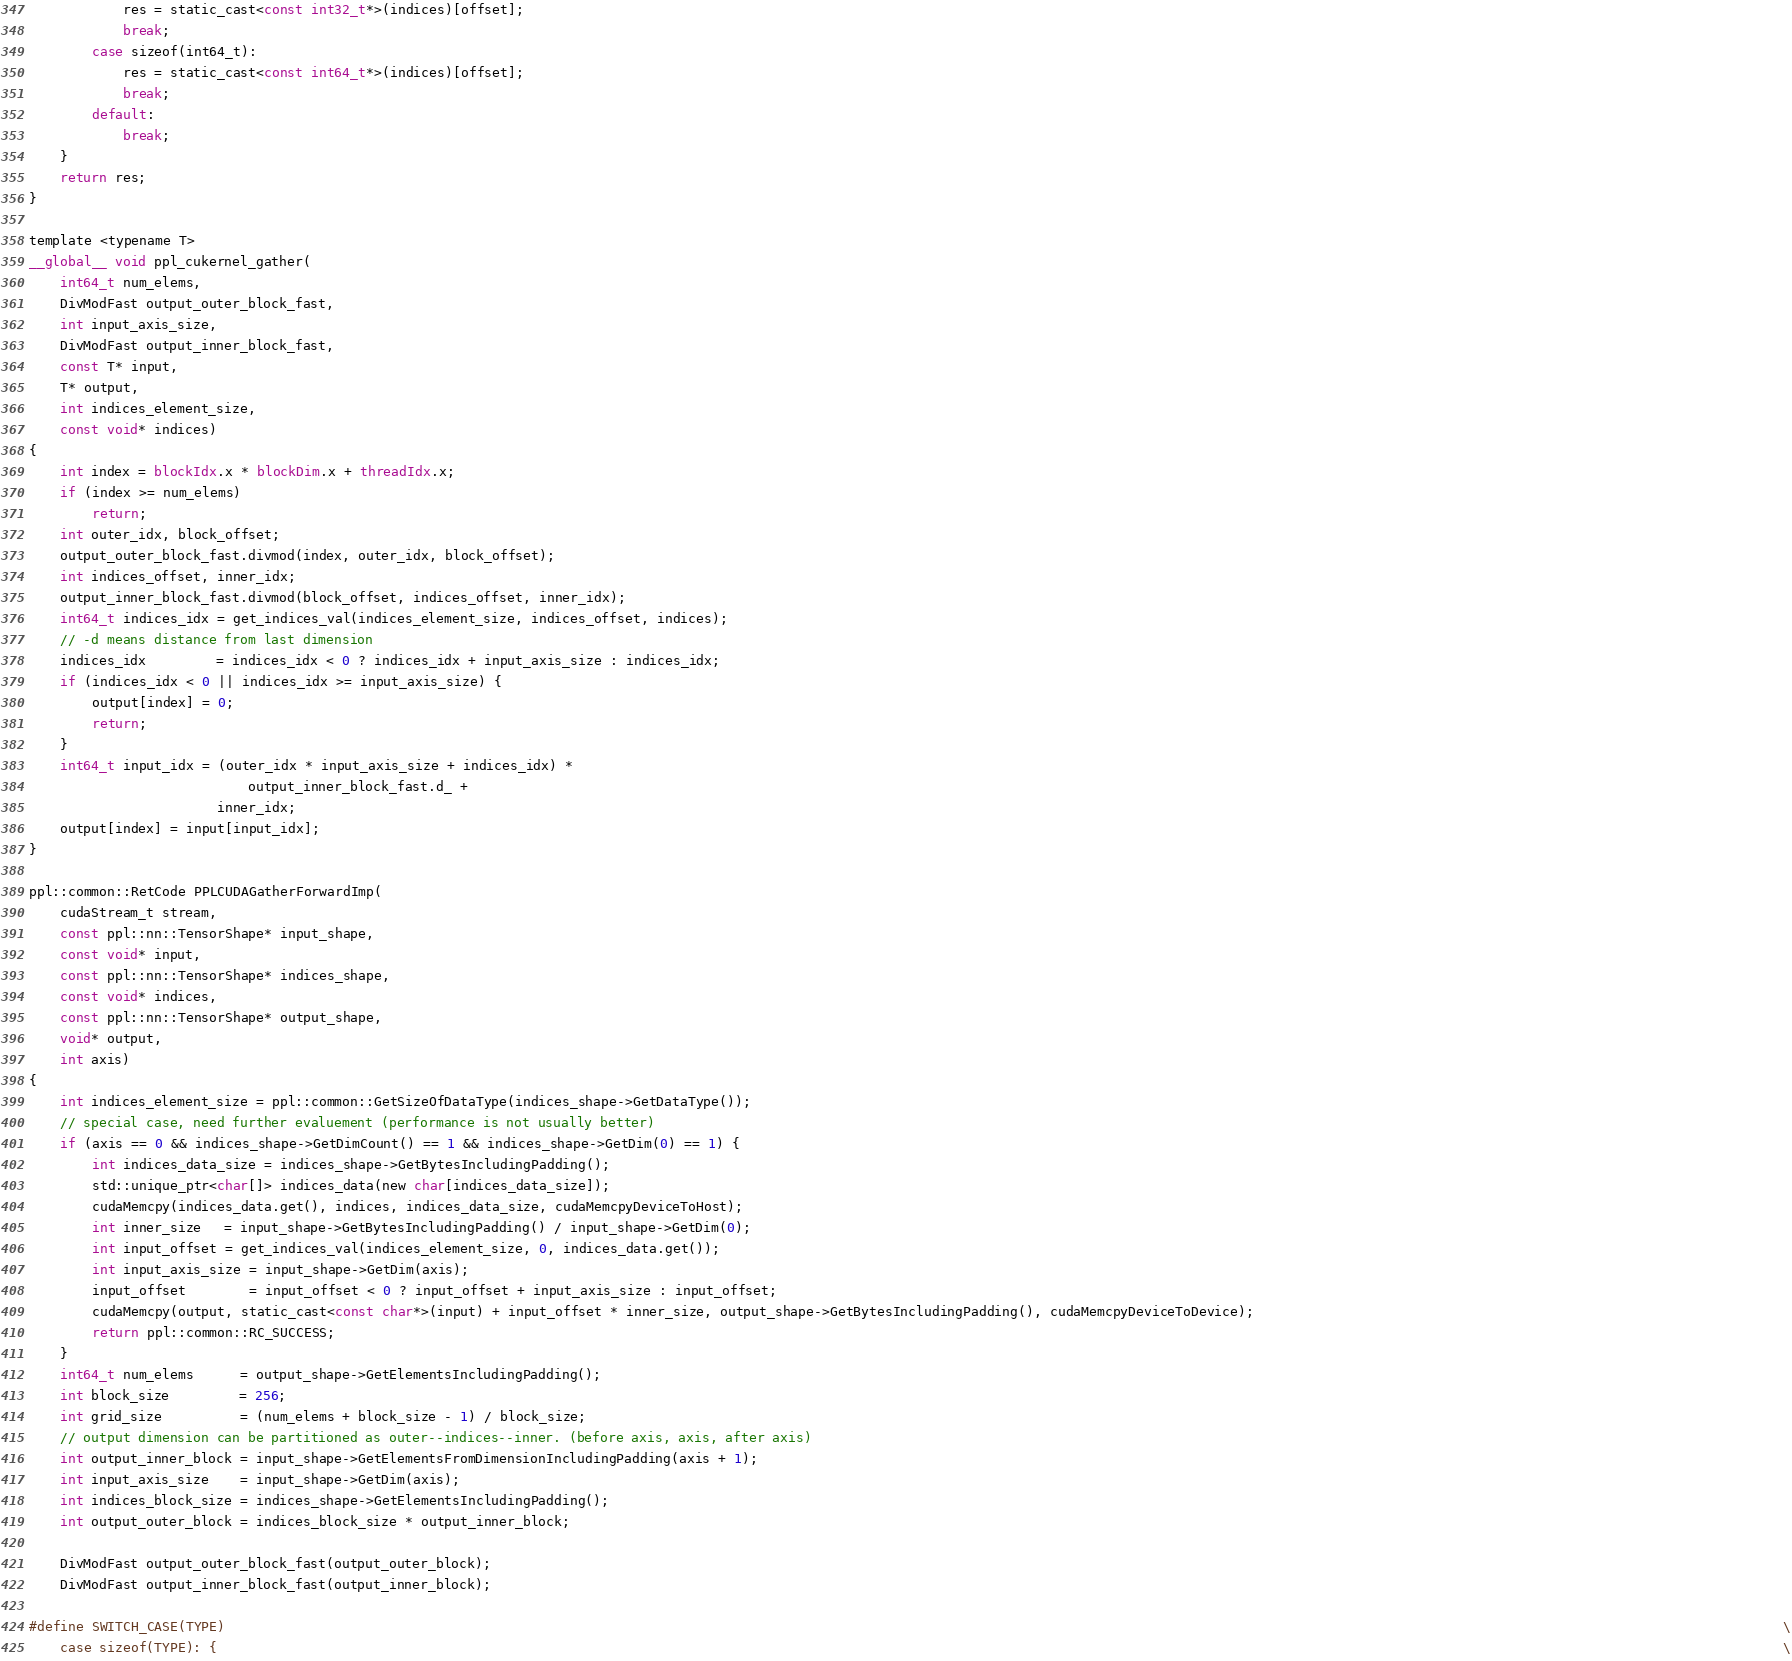Convert code to text. <code><loc_0><loc_0><loc_500><loc_500><_Cuda_>            res = static_cast<const int32_t*>(indices)[offset];
            break;
        case sizeof(int64_t):
            res = static_cast<const int64_t*>(indices)[offset];
            break;
        default:
            break;
    }
    return res;
}

template <typename T>
__global__ void ppl_cukernel_gather(
    int64_t num_elems,
    DivModFast output_outer_block_fast,
    int input_axis_size,
    DivModFast output_inner_block_fast,
    const T* input,
    T* output,
    int indices_element_size,
    const void* indices)
{
    int index = blockIdx.x * blockDim.x + threadIdx.x;
    if (index >= num_elems)
        return;
    int outer_idx, block_offset;
    output_outer_block_fast.divmod(index, outer_idx, block_offset);
    int indices_offset, inner_idx;
    output_inner_block_fast.divmod(block_offset, indices_offset, inner_idx);
    int64_t indices_idx = get_indices_val(indices_element_size, indices_offset, indices);
    // -d means distance from last dimension
    indices_idx         = indices_idx < 0 ? indices_idx + input_axis_size : indices_idx;
    if (indices_idx < 0 || indices_idx >= input_axis_size) {
        output[index] = 0;
        return;
    }
    int64_t input_idx = (outer_idx * input_axis_size + indices_idx) *
                            output_inner_block_fast.d_ +
                        inner_idx;
    output[index] = input[input_idx];
}

ppl::common::RetCode PPLCUDAGatherForwardImp(
    cudaStream_t stream,
    const ppl::nn::TensorShape* input_shape,
    const void* input,
    const ppl::nn::TensorShape* indices_shape,
    const void* indices,
    const ppl::nn::TensorShape* output_shape,
    void* output,
    int axis)
{
    int indices_element_size = ppl::common::GetSizeOfDataType(indices_shape->GetDataType());
    // special case, need further evaluement (performance is not usually better)
    if (axis == 0 && indices_shape->GetDimCount() == 1 && indices_shape->GetDim(0) == 1) {
        int indices_data_size = indices_shape->GetBytesIncludingPadding();
        std::unique_ptr<char[]> indices_data(new char[indices_data_size]);
        cudaMemcpy(indices_data.get(), indices, indices_data_size, cudaMemcpyDeviceToHost);
        int inner_size   = input_shape->GetBytesIncludingPadding() / input_shape->GetDim(0);
        int input_offset = get_indices_val(indices_element_size, 0, indices_data.get());
        int input_axis_size = input_shape->GetDim(axis);
        input_offset        = input_offset < 0 ? input_offset + input_axis_size : input_offset;
        cudaMemcpy(output, static_cast<const char*>(input) + input_offset * inner_size, output_shape->GetBytesIncludingPadding(), cudaMemcpyDeviceToDevice);
        return ppl::common::RC_SUCCESS;
    }
    int64_t num_elems      = output_shape->GetElementsIncludingPadding();
    int block_size         = 256;
    int grid_size          = (num_elems + block_size - 1) / block_size;
    // output dimension can be partitioned as outer--indices--inner. (before axis, axis, after axis)
    int output_inner_block = input_shape->GetElementsFromDimensionIncludingPadding(axis + 1);
    int input_axis_size    = input_shape->GetDim(axis);
    int indices_block_size = indices_shape->GetElementsIncludingPadding();
    int output_outer_block = indices_block_size * output_inner_block;

    DivModFast output_outer_block_fast(output_outer_block);
    DivModFast output_inner_block_fast(output_inner_block);

#define SWITCH_CASE(TYPE)                                                                                                                                                                                                       \
    case sizeof(TYPE): {                                                                                                                                                                                                        \</code> 